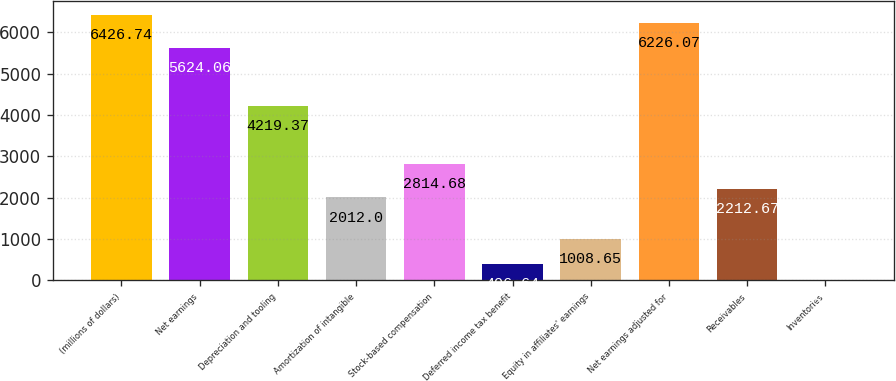Convert chart. <chart><loc_0><loc_0><loc_500><loc_500><bar_chart><fcel>(millions of dollars)<fcel>Net earnings<fcel>Depreciation and tooling<fcel>Amortization of intangible<fcel>Stock-based compensation<fcel>Deferred income tax benefit<fcel>Equity in affiliates' earnings<fcel>Net earnings adjusted for<fcel>Receivables<fcel>Inventories<nl><fcel>6426.74<fcel>5624.06<fcel>4219.37<fcel>2012<fcel>2814.68<fcel>406.64<fcel>1008.65<fcel>6226.07<fcel>2212.67<fcel>5.3<nl></chart> 